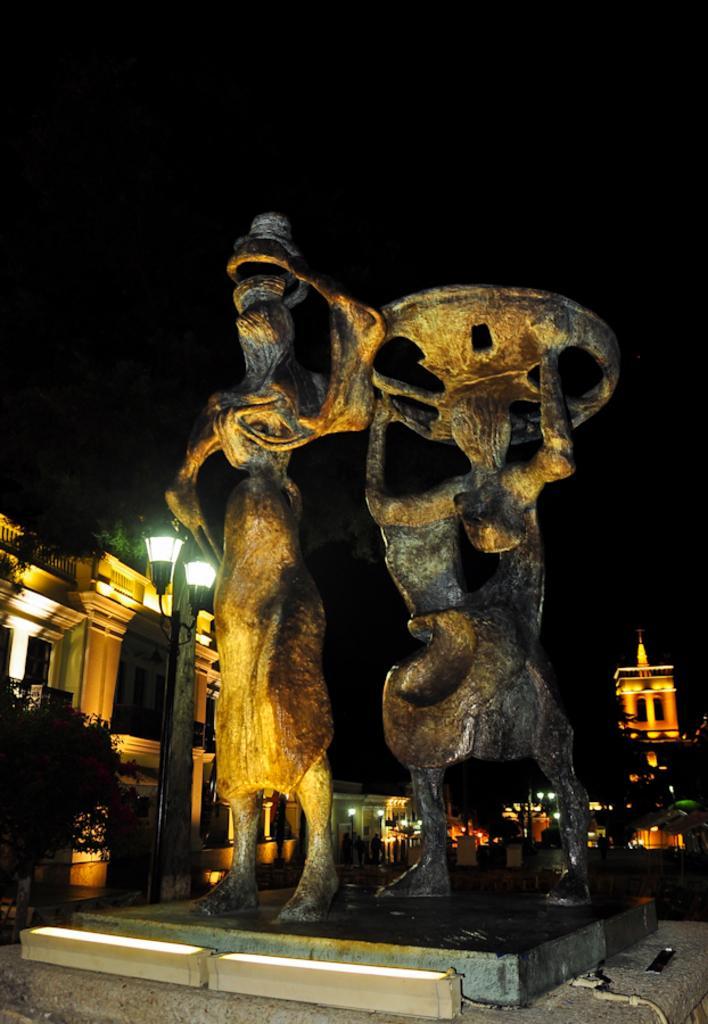In one or two sentences, can you explain what this image depicts? This is clicked at night time, there are two statues in the middle and in the background there are buildings with many lights and trees in front of it. 